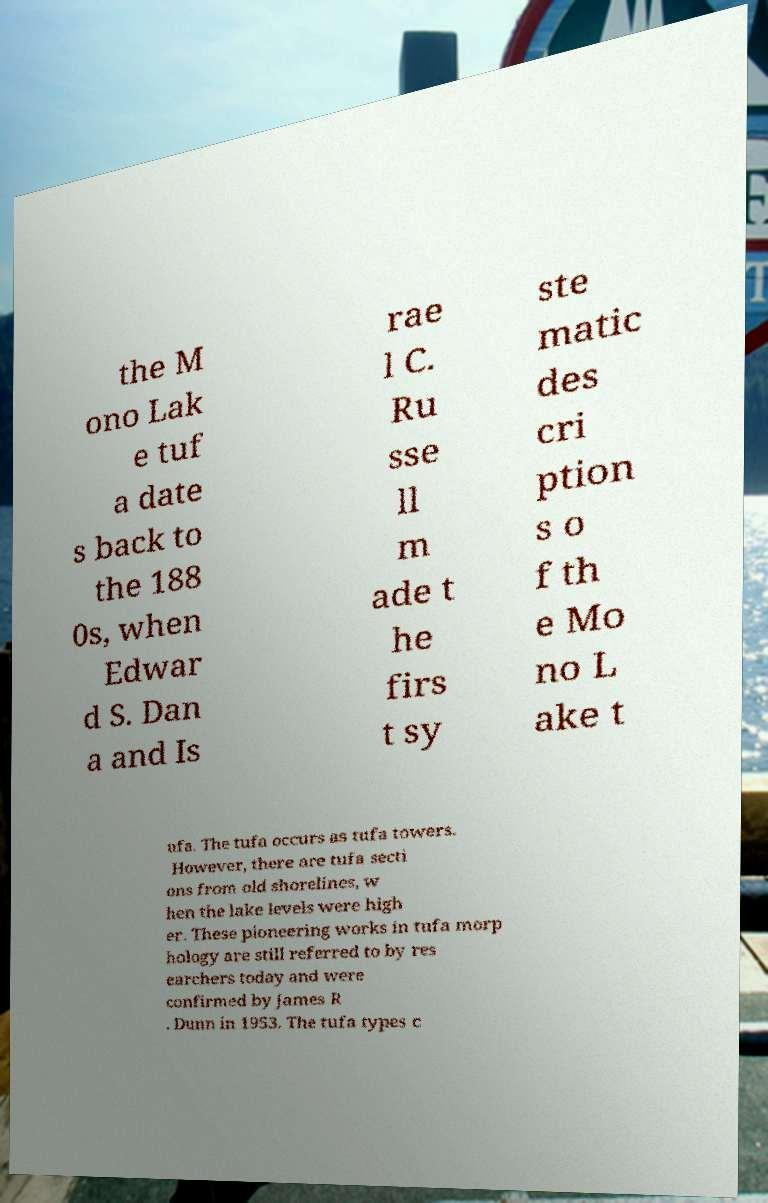What messages or text are displayed in this image? I need them in a readable, typed format. the M ono Lak e tuf a date s back to the 188 0s, when Edwar d S. Dan a and Is rae l C. Ru sse ll m ade t he firs t sy ste matic des cri ption s o f th e Mo no L ake t ufa. The tufa occurs as tufa towers. However, there are tufa secti ons from old shorelines, w hen the lake levels were high er. These pioneering works in tufa morp hology are still referred to by res earchers today and were confirmed by James R . Dunn in 1953. The tufa types c 